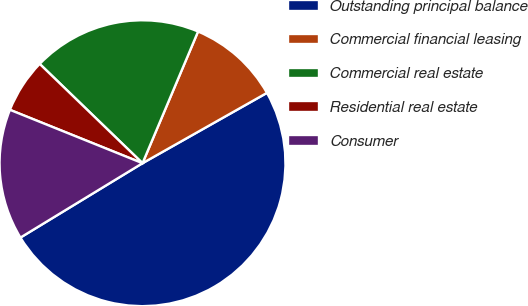Convert chart to OTSL. <chart><loc_0><loc_0><loc_500><loc_500><pie_chart><fcel>Outstanding principal balance<fcel>Commercial financial leasing<fcel>Commercial real estate<fcel>Residential real estate<fcel>Consumer<nl><fcel>49.48%<fcel>10.46%<fcel>19.13%<fcel>6.13%<fcel>14.8%<nl></chart> 